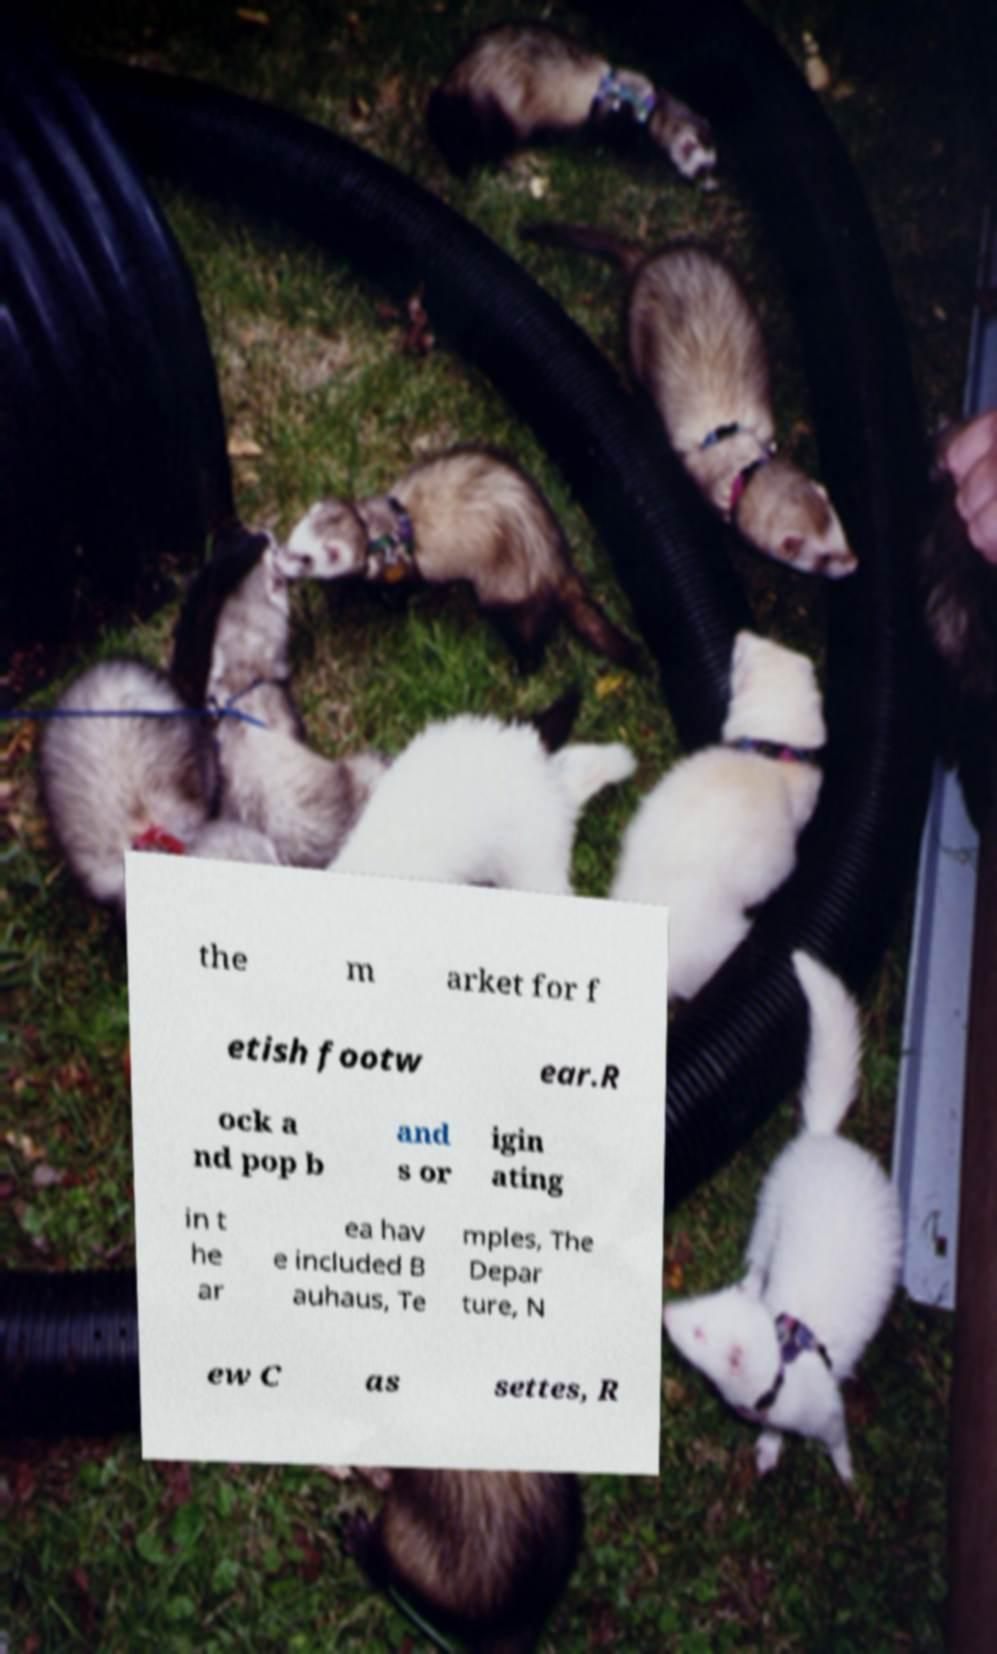Please identify and transcribe the text found in this image. the m arket for f etish footw ear.R ock a nd pop b and s or igin ating in t he ar ea hav e included B auhaus, Te mples, The Depar ture, N ew C as settes, R 